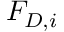Convert formula to latex. <formula><loc_0><loc_0><loc_500><loc_500>F _ { D , i }</formula> 